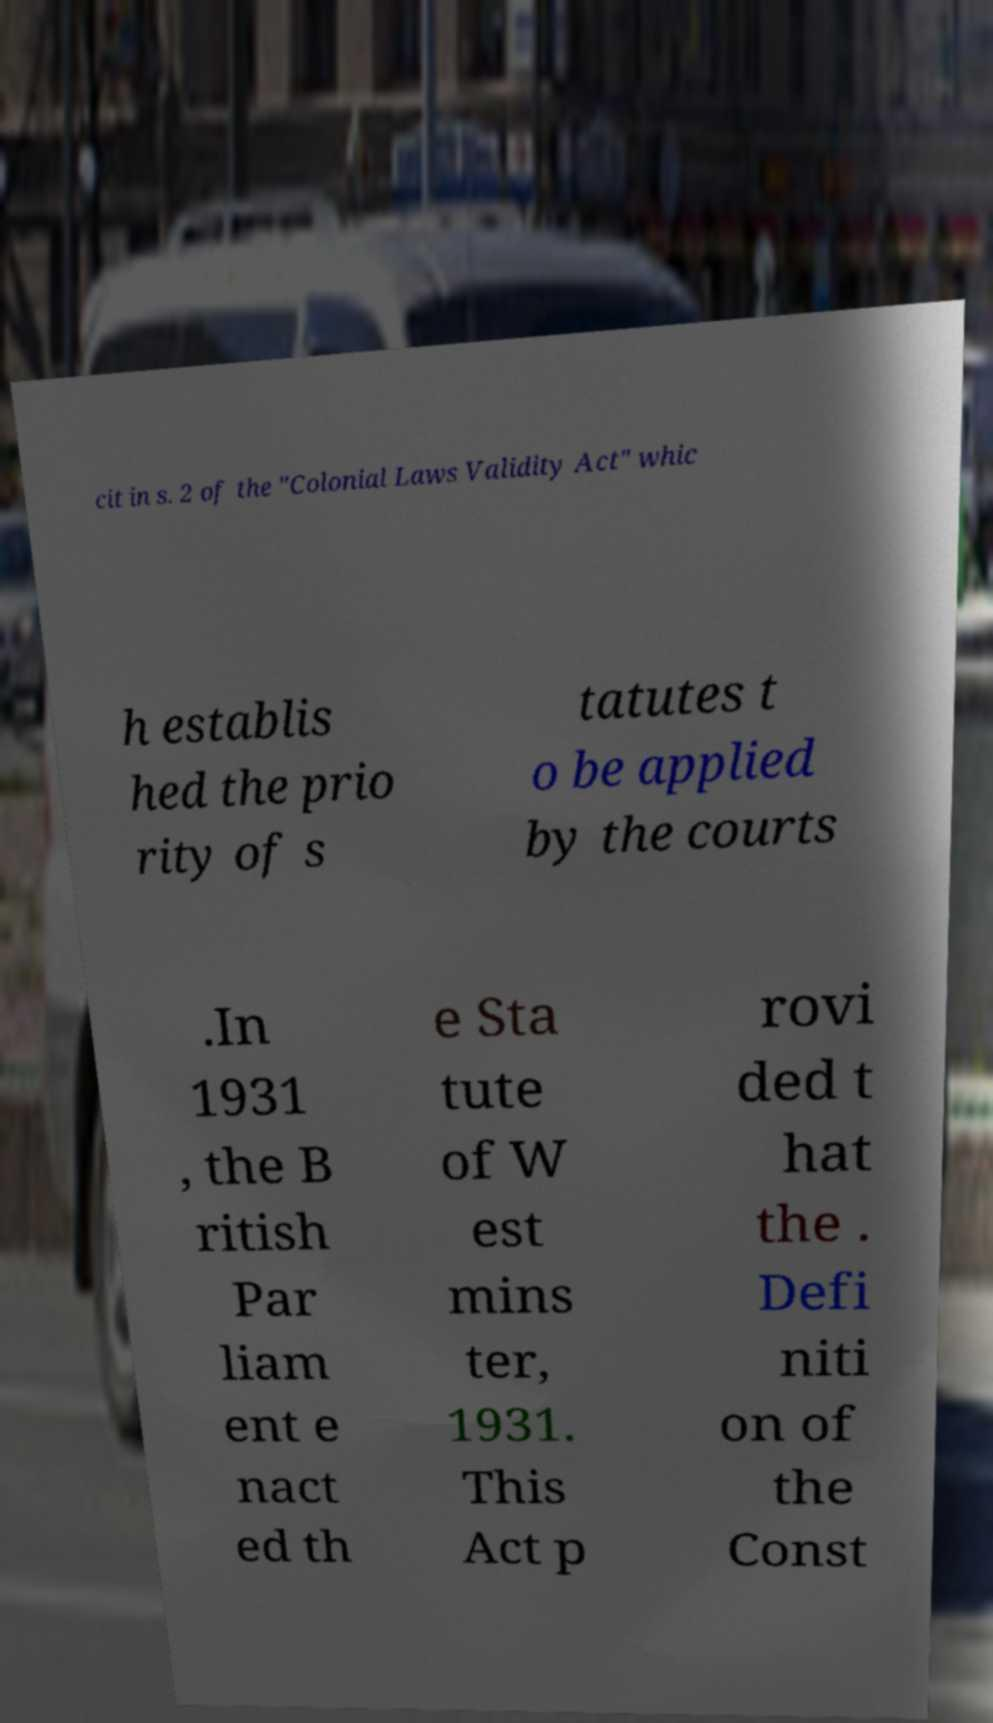Could you extract and type out the text from this image? cit in s. 2 of the "Colonial Laws Validity Act" whic h establis hed the prio rity of s tatutes t o be applied by the courts .In 1931 , the B ritish Par liam ent e nact ed th e Sta tute of W est mins ter, 1931. This Act p rovi ded t hat the . Defi niti on of the Const 